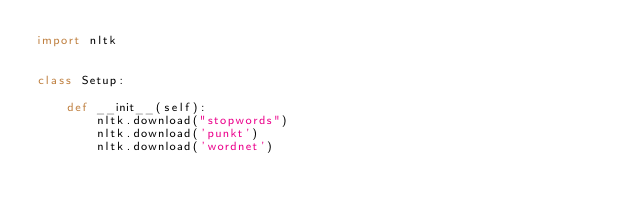<code> <loc_0><loc_0><loc_500><loc_500><_Python_>import nltk


class Setup:

    def __init__(self):
        nltk.download("stopwords")
        nltk.download('punkt')
        nltk.download('wordnet')
</code> 